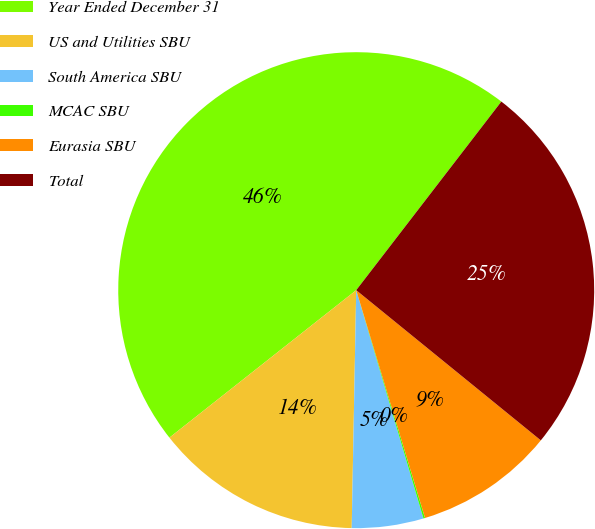Convert chart to OTSL. <chart><loc_0><loc_0><loc_500><loc_500><pie_chart><fcel>Year Ended December 31<fcel>US and Utilities SBU<fcel>South America SBU<fcel>MCAC SBU<fcel>Eurasia SBU<fcel>Total<nl><fcel>46.07%<fcel>14.06%<fcel>4.86%<fcel>0.11%<fcel>9.46%<fcel>25.43%<nl></chart> 